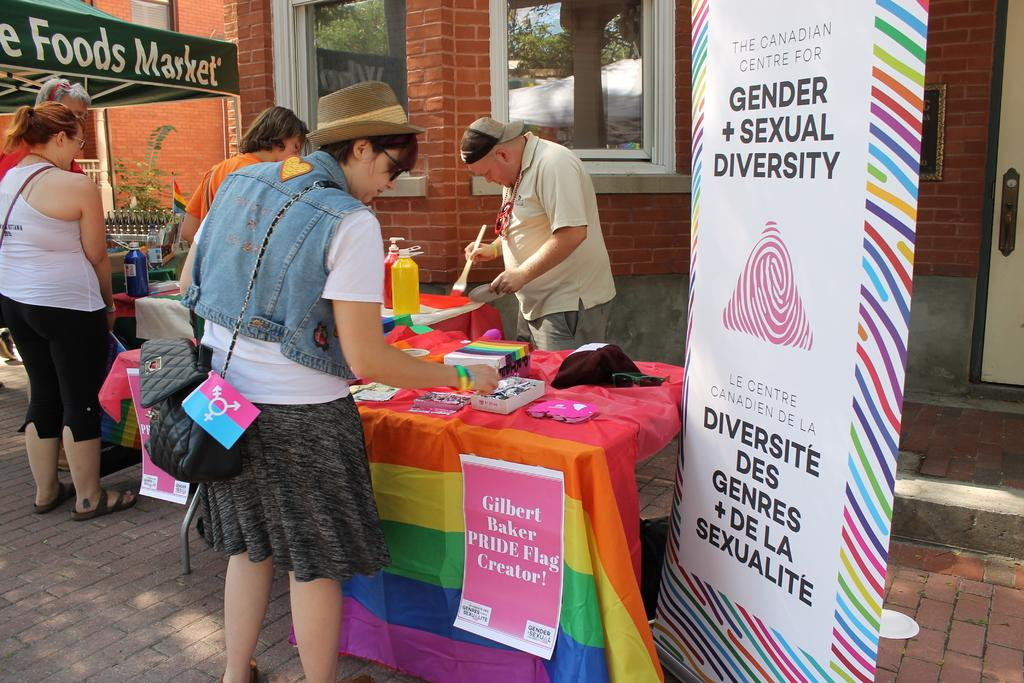What is happening in the image? There is a group of persons in the image, and they are standing and doing some work. Can you describe any additional elements in the image? Yes, there is a banner on the right side of the image. What type of leaf is hanging from the string on the left side of the image? There is no leaf or string present in the image. 